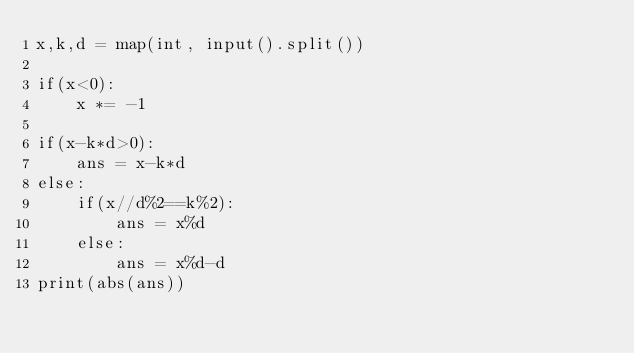<code> <loc_0><loc_0><loc_500><loc_500><_Python_>x,k,d = map(int, input().split())

if(x<0):
    x *= -1

if(x-k*d>0):
    ans = x-k*d
else:
    if(x//d%2==k%2):
        ans = x%d
    else:
        ans = x%d-d
print(abs(ans))
    

</code> 